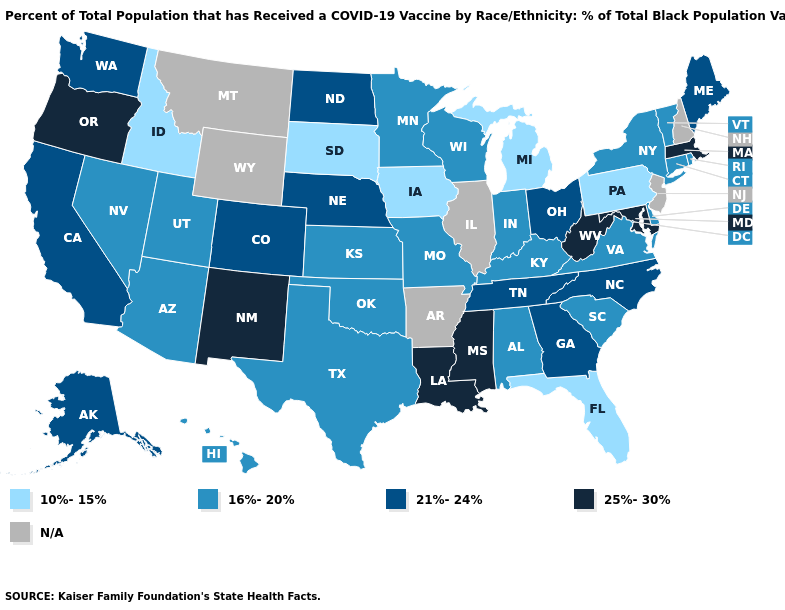What is the lowest value in the MidWest?
Concise answer only. 10%-15%. What is the value of Arkansas?
Write a very short answer. N/A. Name the states that have a value in the range 25%-30%?
Be succinct. Louisiana, Maryland, Massachusetts, Mississippi, New Mexico, Oregon, West Virginia. What is the value of New Hampshire?
Be succinct. N/A. Name the states that have a value in the range 10%-15%?
Give a very brief answer. Florida, Idaho, Iowa, Michigan, Pennsylvania, South Dakota. What is the value of Louisiana?
Be succinct. 25%-30%. Which states have the highest value in the USA?
Give a very brief answer. Louisiana, Maryland, Massachusetts, Mississippi, New Mexico, Oregon, West Virginia. Does the map have missing data?
Answer briefly. Yes. What is the lowest value in the USA?
Short answer required. 10%-15%. What is the value of Missouri?
Concise answer only. 16%-20%. Does Rhode Island have the lowest value in the USA?
Be succinct. No. What is the value of Ohio?
Short answer required. 21%-24%. 